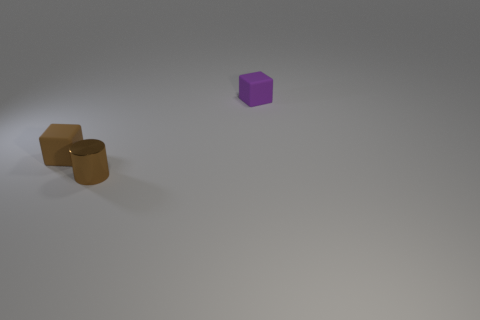Add 3 big green things. How many objects exist? 6 Subtract all cubes. How many objects are left? 1 Subtract all tiny metal cylinders. Subtract all small metallic things. How many objects are left? 1 Add 1 tiny metallic cylinders. How many tiny metallic cylinders are left? 2 Add 1 brown matte things. How many brown matte things exist? 2 Subtract 0 brown spheres. How many objects are left? 3 